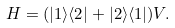Convert formula to latex. <formula><loc_0><loc_0><loc_500><loc_500>H = ( | 1 \rangle \langle 2 | + | 2 \rangle \langle 1 | ) V .</formula> 